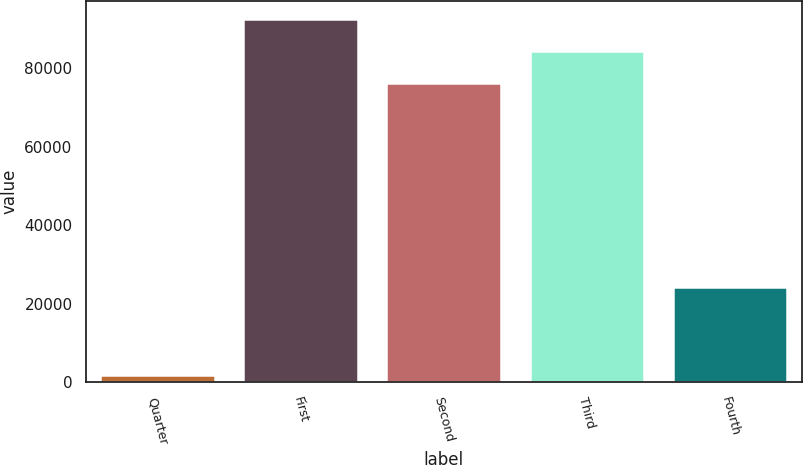Convert chart. <chart><loc_0><loc_0><loc_500><loc_500><bar_chart><fcel>Quarter<fcel>First<fcel>Second<fcel>Third<fcel>Fourth<nl><fcel>2011<fcel>92594.4<fcel>76188<fcel>84391.2<fcel>24394<nl></chart> 